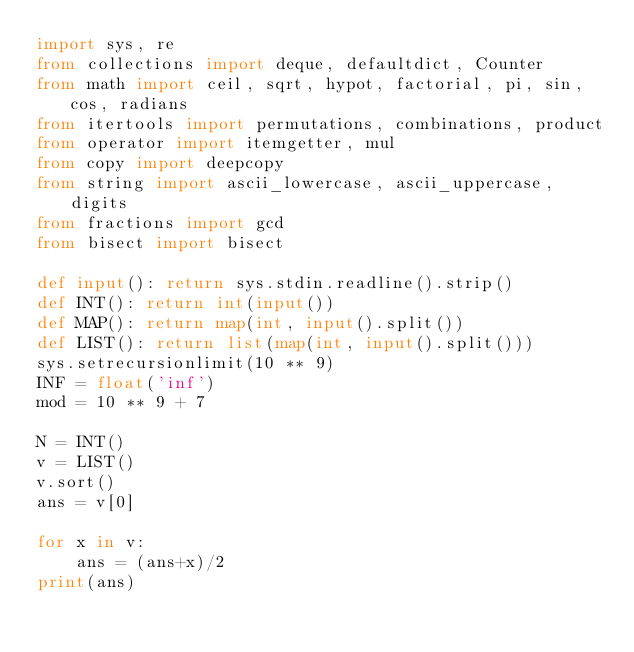Convert code to text. <code><loc_0><loc_0><loc_500><loc_500><_Python_>import sys, re
from collections import deque, defaultdict, Counter
from math import ceil, sqrt, hypot, factorial, pi, sin, cos, radians
from itertools import permutations, combinations, product
from operator import itemgetter, mul
from copy import deepcopy
from string import ascii_lowercase, ascii_uppercase, digits
from fractions import gcd
from bisect import bisect

def input(): return sys.stdin.readline().strip()
def INT(): return int(input())
def MAP(): return map(int, input().split())
def LIST(): return list(map(int, input().split()))
sys.setrecursionlimit(10 ** 9)
INF = float('inf')
mod = 10 ** 9 + 7

N = INT()
v = LIST()
v.sort()
ans = v[0]

for x in v:
	ans = (ans+x)/2
print(ans)
</code> 